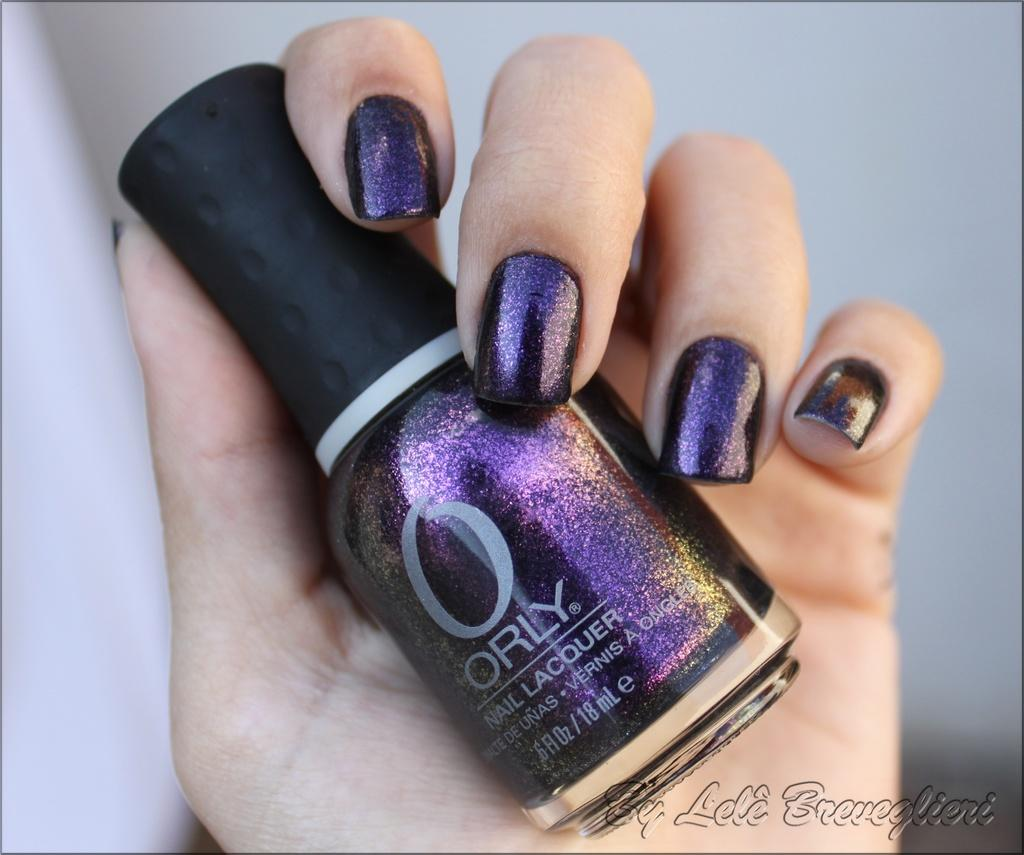What is the person holding in the image? The person is holding a nail-polish bottle in the image. Can you describe the person's hand in the image? There is a person's hand in the image, holding the nail-polish bottle. What might be visible in the background of the image? There might be a wall visible in the background of the image. What is written at the bottom of the image? There is text at the bottom of the image. What instrument is the person playing in the image? There is no instrument present in the image; the person is holding a nail-polish bottle. 